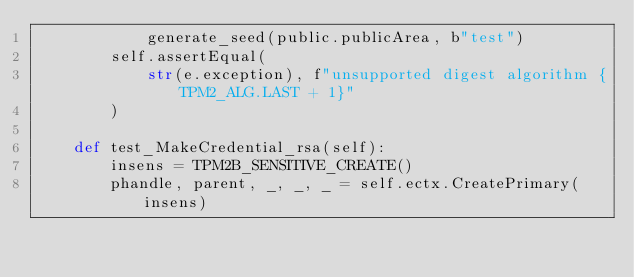Convert code to text. <code><loc_0><loc_0><loc_500><loc_500><_Python_>            generate_seed(public.publicArea, b"test")
        self.assertEqual(
            str(e.exception), f"unsupported digest algorithm {TPM2_ALG.LAST + 1}"
        )

    def test_MakeCredential_rsa(self):
        insens = TPM2B_SENSITIVE_CREATE()
        phandle, parent, _, _, _ = self.ectx.CreatePrimary(insens)</code> 